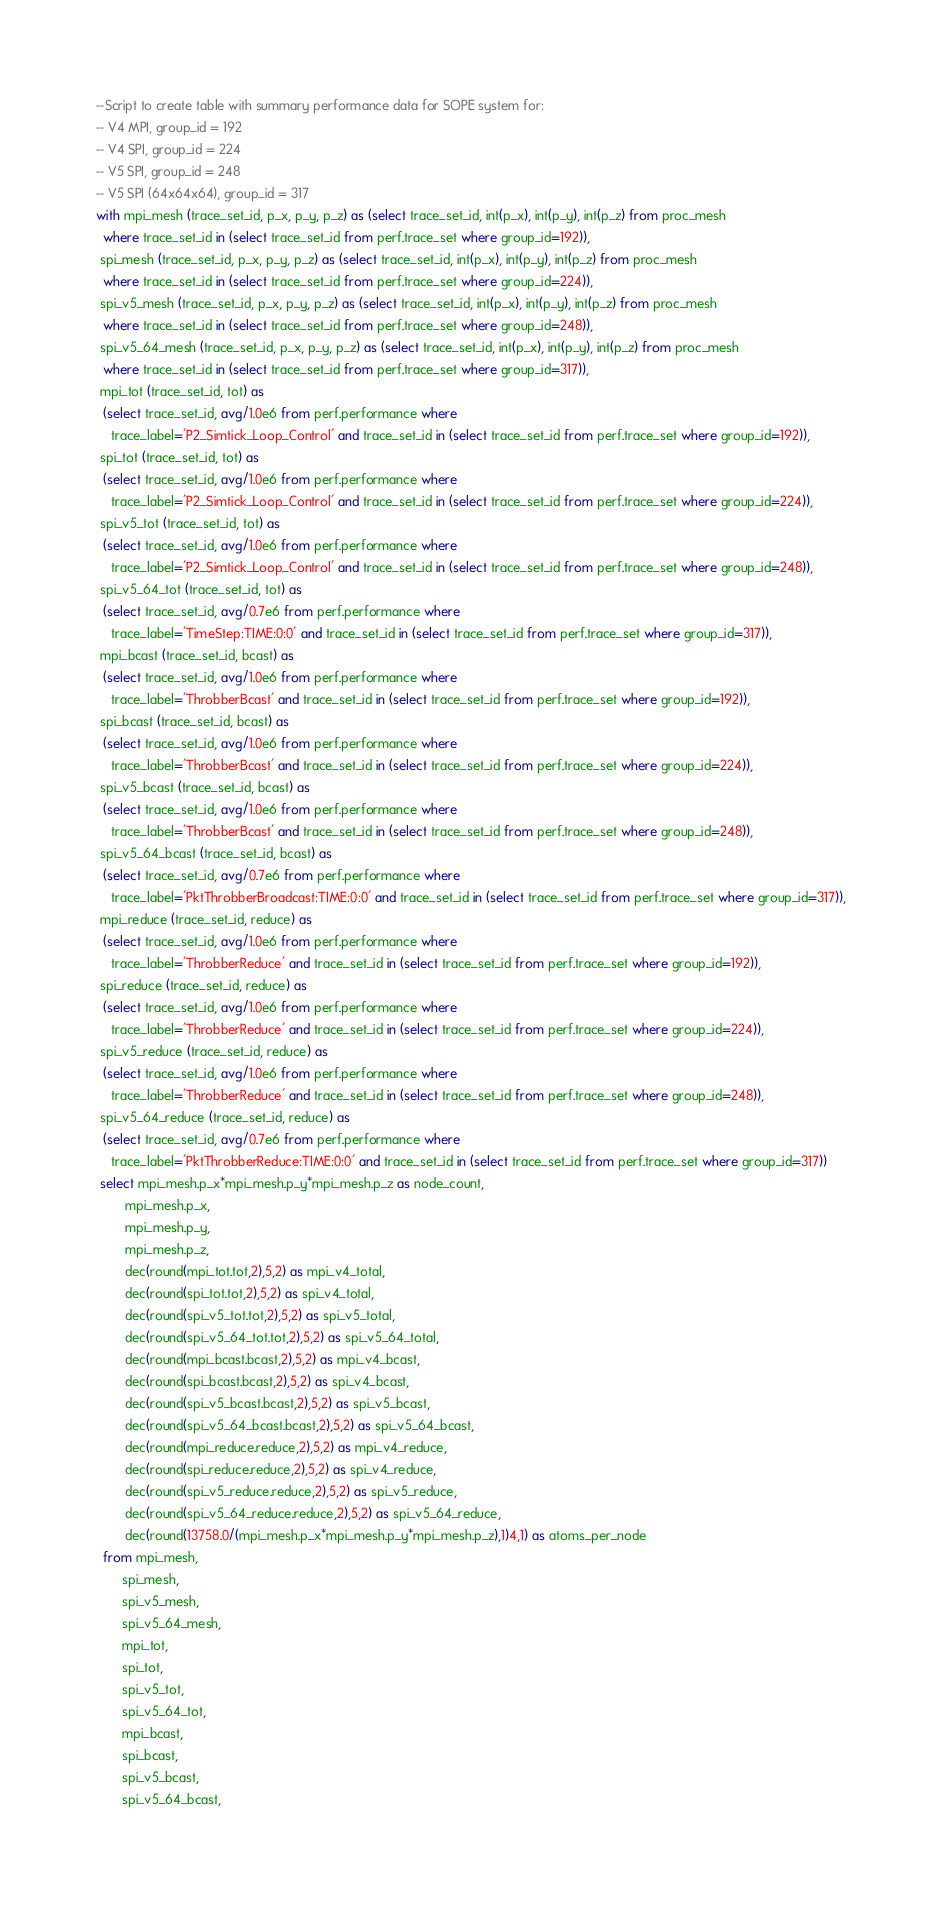<code> <loc_0><loc_0><loc_500><loc_500><_SQL_>--Script to create table with summary performance data for SOPE system for:
-- V4 MPI, group_id = 192
-- V4 SPI, group_id = 224
-- V5 SPI, group_id = 248
-- V5 SPI (64x64x64), group_id = 317
with mpi_mesh (trace_set_id, p_x, p_y, p_z) as (select trace_set_id, int(p_x), int(p_y), int(p_z) from proc_mesh
  where trace_set_id in (select trace_set_id from perf.trace_set where group_id=192)),
 spi_mesh (trace_set_id, p_x, p_y, p_z) as (select trace_set_id, int(p_x), int(p_y), int(p_z) from proc_mesh
  where trace_set_id in (select trace_set_id from perf.trace_set where group_id=224)),
 spi_v5_mesh (trace_set_id, p_x, p_y, p_z) as (select trace_set_id, int(p_x), int(p_y), int(p_z) from proc_mesh
  where trace_set_id in (select trace_set_id from perf.trace_set where group_id=248)),
 spi_v5_64_mesh (trace_set_id, p_x, p_y, p_z) as (select trace_set_id, int(p_x), int(p_y), int(p_z) from proc_mesh
  where trace_set_id in (select trace_set_id from perf.trace_set where group_id=317)),
 mpi_tot (trace_set_id, tot) as
  (select trace_set_id, avg/1.0e6 from perf.performance where
    trace_label='P2_Simtick_Loop_Control' and trace_set_id in (select trace_set_id from perf.trace_set where group_id=192)),
 spi_tot (trace_set_id, tot) as
  (select trace_set_id, avg/1.0e6 from perf.performance where
    trace_label='P2_Simtick_Loop_Control' and trace_set_id in (select trace_set_id from perf.trace_set where group_id=224)),
 spi_v5_tot (trace_set_id, tot) as
  (select trace_set_id, avg/1.0e6 from perf.performance where
    trace_label='P2_Simtick_Loop_Control' and trace_set_id in (select trace_set_id from perf.trace_set where group_id=248)),
 spi_v5_64_tot (trace_set_id, tot) as
  (select trace_set_id, avg/0.7e6 from perf.performance where
    trace_label='TimeStep:TIME:0:0' and trace_set_id in (select trace_set_id from perf.trace_set where group_id=317)),
 mpi_bcast (trace_set_id, bcast) as
  (select trace_set_id, avg/1.0e6 from perf.performance where
    trace_label='ThrobberBcast' and trace_set_id in (select trace_set_id from perf.trace_set where group_id=192)),
 spi_bcast (trace_set_id, bcast) as
  (select trace_set_id, avg/1.0e6 from perf.performance where
    trace_label='ThrobberBcast' and trace_set_id in (select trace_set_id from perf.trace_set where group_id=224)),
 spi_v5_bcast (trace_set_id, bcast) as
  (select trace_set_id, avg/1.0e6 from perf.performance where
    trace_label='ThrobberBcast' and trace_set_id in (select trace_set_id from perf.trace_set where group_id=248)),
 spi_v5_64_bcast (trace_set_id, bcast) as
  (select trace_set_id, avg/0.7e6 from perf.performance where
    trace_label='PktThrobberBroadcast:TIME:0:0' and trace_set_id in (select trace_set_id from perf.trace_set where group_id=317)),
 mpi_reduce (trace_set_id, reduce) as
  (select trace_set_id, avg/1.0e6 from perf.performance where
    trace_label='ThrobberReduce' and trace_set_id in (select trace_set_id from perf.trace_set where group_id=192)),
 spi_reduce (trace_set_id, reduce) as
  (select trace_set_id, avg/1.0e6 from perf.performance where
    trace_label='ThrobberReduce' and trace_set_id in (select trace_set_id from perf.trace_set where group_id=224)),
 spi_v5_reduce (trace_set_id, reduce) as
  (select trace_set_id, avg/1.0e6 from perf.performance where
    trace_label='ThrobberReduce' and trace_set_id in (select trace_set_id from perf.trace_set where group_id=248)),
 spi_v5_64_reduce (trace_set_id, reduce) as
  (select trace_set_id, avg/0.7e6 from perf.performance where
    trace_label='PktThrobberReduce:TIME:0:0' and trace_set_id in (select trace_set_id from perf.trace_set where group_id=317))
 select mpi_mesh.p_x*mpi_mesh.p_y*mpi_mesh.p_z as node_count,
        mpi_mesh.p_x,
        mpi_mesh.p_y,
        mpi_mesh.p_z, 
        dec(round(mpi_tot.tot,2),5,2) as mpi_v4_total,
        dec(round(spi_tot.tot,2),5,2) as spi_v4_total,
        dec(round(spi_v5_tot.tot,2),5,2) as spi_v5_total,
        dec(round(spi_v5_64_tot.tot,2),5,2) as spi_v5_64_total,
        dec(round(mpi_bcast.bcast,2),5,2) as mpi_v4_bcast,
        dec(round(spi_bcast.bcast,2),5,2) as spi_v4_bcast,
        dec(round(spi_v5_bcast.bcast,2),5,2) as spi_v5_bcast,
        dec(round(spi_v5_64_bcast.bcast,2),5,2) as spi_v5_64_bcast,
        dec(round(mpi_reduce.reduce,2),5,2) as mpi_v4_reduce,
        dec(round(spi_reduce.reduce,2),5,2) as spi_v4_reduce,
        dec(round(spi_v5_reduce.reduce,2),5,2) as spi_v5_reduce,
        dec(round(spi_v5_64_reduce.reduce,2),5,2) as spi_v5_64_reduce,
        dec(round(13758.0/(mpi_mesh.p_x*mpi_mesh.p_y*mpi_mesh.p_z),1)4,1) as atoms_per_node
  from mpi_mesh,
       spi_mesh,
       spi_v5_mesh,
       spi_v5_64_mesh,
       mpi_tot, 
       spi_tot,
       spi_v5_tot,
       spi_v5_64_tot,
       mpi_bcast, 
       spi_bcast, 
       spi_v5_bcast, 
       spi_v5_64_bcast, </code> 